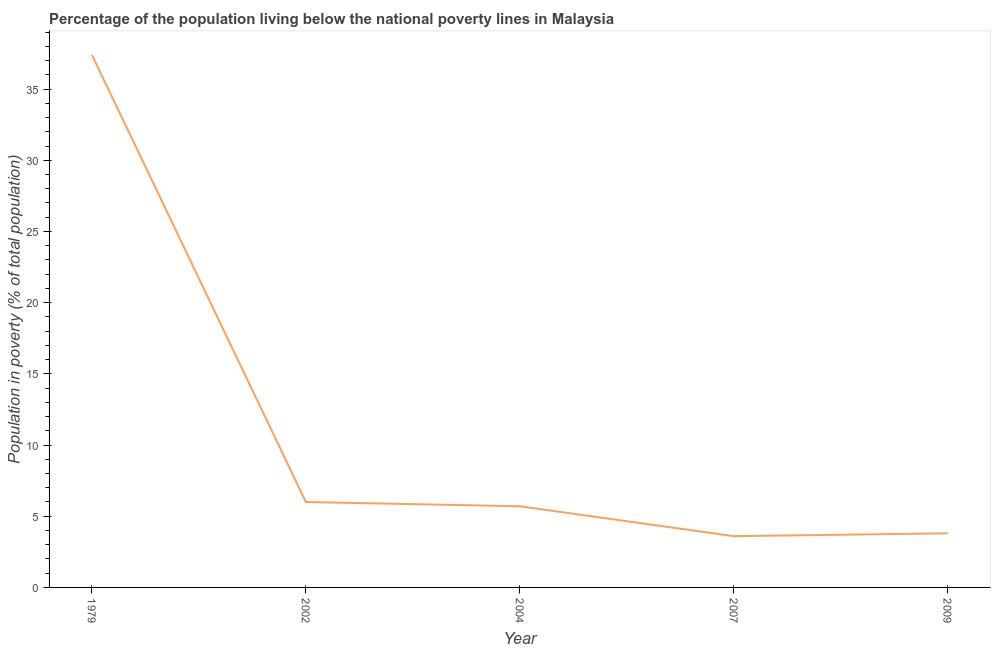What is the percentage of population living below poverty line in 1979?
Your response must be concise. 37.4. Across all years, what is the maximum percentage of population living below poverty line?
Keep it short and to the point. 37.4. In which year was the percentage of population living below poverty line maximum?
Ensure brevity in your answer.  1979. In which year was the percentage of population living below poverty line minimum?
Ensure brevity in your answer.  2007. What is the sum of the percentage of population living below poverty line?
Your answer should be compact. 56.5. What is the difference between the percentage of population living below poverty line in 2002 and 2009?
Your response must be concise. 2.2. Do a majority of the years between 1979 and 2009 (inclusive) have percentage of population living below poverty line greater than 3 %?
Your answer should be compact. Yes. What is the ratio of the percentage of population living below poverty line in 1979 to that in 2009?
Keep it short and to the point. 9.84. Is the percentage of population living below poverty line in 1979 less than that in 2002?
Your answer should be very brief. No. Is the difference between the percentage of population living below poverty line in 2002 and 2007 greater than the difference between any two years?
Provide a succinct answer. No. What is the difference between the highest and the second highest percentage of population living below poverty line?
Keep it short and to the point. 31.4. What is the difference between the highest and the lowest percentage of population living below poverty line?
Your answer should be compact. 33.8. Does the percentage of population living below poverty line monotonically increase over the years?
Provide a succinct answer. No. How many lines are there?
Provide a succinct answer. 1. How many years are there in the graph?
Offer a terse response. 5. Are the values on the major ticks of Y-axis written in scientific E-notation?
Provide a succinct answer. No. Does the graph contain grids?
Your answer should be very brief. No. What is the title of the graph?
Ensure brevity in your answer.  Percentage of the population living below the national poverty lines in Malaysia. What is the label or title of the Y-axis?
Ensure brevity in your answer.  Population in poverty (% of total population). What is the Population in poverty (% of total population) of 1979?
Ensure brevity in your answer.  37.4. What is the Population in poverty (% of total population) of 2004?
Give a very brief answer. 5.7. What is the Population in poverty (% of total population) of 2007?
Give a very brief answer. 3.6. What is the Population in poverty (% of total population) in 2009?
Your answer should be very brief. 3.8. What is the difference between the Population in poverty (% of total population) in 1979 and 2002?
Your answer should be compact. 31.4. What is the difference between the Population in poverty (% of total population) in 1979 and 2004?
Your answer should be compact. 31.7. What is the difference between the Population in poverty (% of total population) in 1979 and 2007?
Keep it short and to the point. 33.8. What is the difference between the Population in poverty (% of total population) in 1979 and 2009?
Offer a very short reply. 33.6. What is the difference between the Population in poverty (% of total population) in 2007 and 2009?
Your response must be concise. -0.2. What is the ratio of the Population in poverty (% of total population) in 1979 to that in 2002?
Offer a very short reply. 6.23. What is the ratio of the Population in poverty (% of total population) in 1979 to that in 2004?
Your answer should be compact. 6.56. What is the ratio of the Population in poverty (% of total population) in 1979 to that in 2007?
Give a very brief answer. 10.39. What is the ratio of the Population in poverty (% of total population) in 1979 to that in 2009?
Your answer should be very brief. 9.84. What is the ratio of the Population in poverty (% of total population) in 2002 to that in 2004?
Provide a short and direct response. 1.05. What is the ratio of the Population in poverty (% of total population) in 2002 to that in 2007?
Provide a short and direct response. 1.67. What is the ratio of the Population in poverty (% of total population) in 2002 to that in 2009?
Provide a succinct answer. 1.58. What is the ratio of the Population in poverty (% of total population) in 2004 to that in 2007?
Your answer should be very brief. 1.58. What is the ratio of the Population in poverty (% of total population) in 2007 to that in 2009?
Offer a terse response. 0.95. 